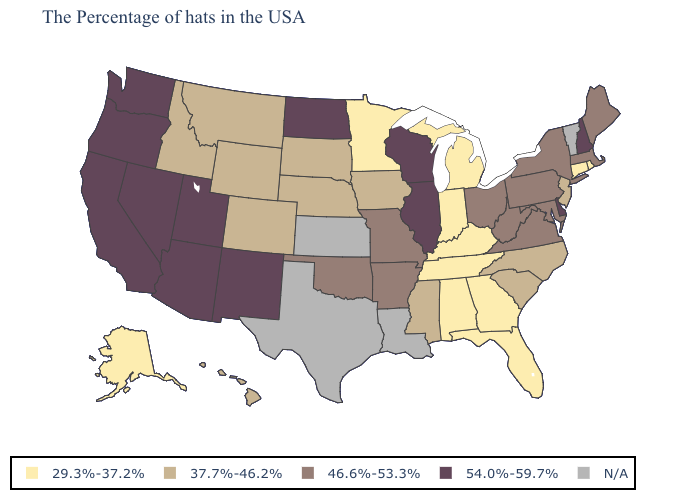What is the value of Indiana?
Answer briefly. 29.3%-37.2%. What is the value of South Carolina?
Answer briefly. 37.7%-46.2%. Does the map have missing data?
Write a very short answer. Yes. What is the highest value in the Northeast ?
Give a very brief answer. 54.0%-59.7%. Name the states that have a value in the range N/A?
Write a very short answer. Vermont, Louisiana, Kansas, Texas. What is the value of Virginia?
Answer briefly. 46.6%-53.3%. What is the lowest value in states that border Virginia?
Be succinct. 29.3%-37.2%. Name the states that have a value in the range 29.3%-37.2%?
Quick response, please. Rhode Island, Connecticut, Florida, Georgia, Michigan, Kentucky, Indiana, Alabama, Tennessee, Minnesota, Alaska. Which states have the highest value in the USA?
Keep it brief. New Hampshire, Delaware, Wisconsin, Illinois, North Dakota, New Mexico, Utah, Arizona, Nevada, California, Washington, Oregon. What is the value of Alabama?
Be succinct. 29.3%-37.2%. What is the highest value in states that border Vermont?
Quick response, please. 54.0%-59.7%. 